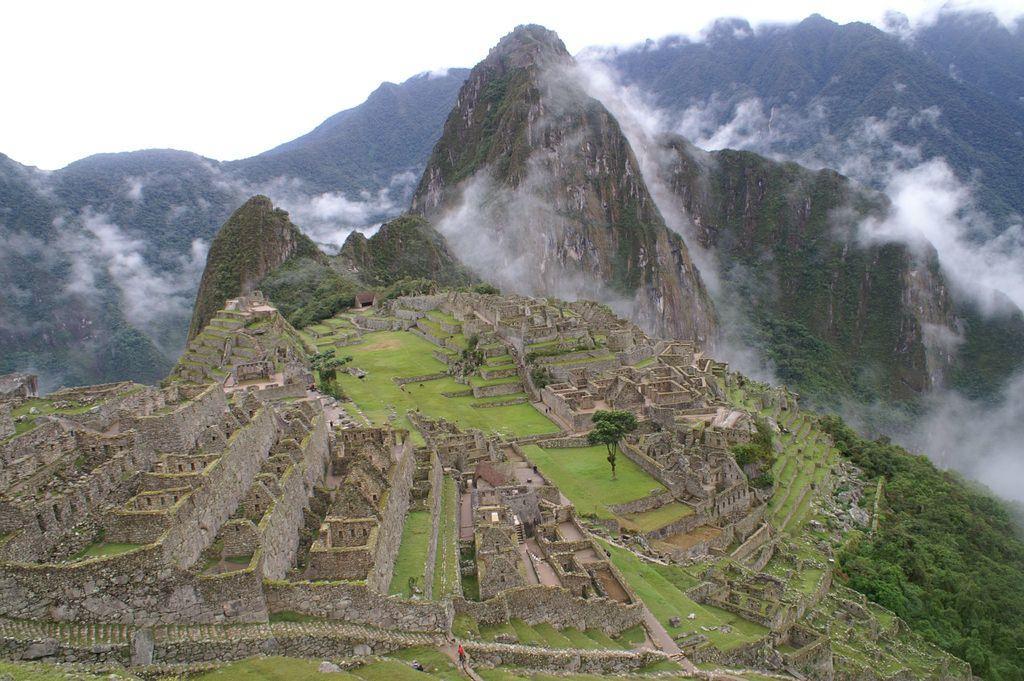Describe this image in one or two sentences. In this image I can see a top view of a city which is ruined and I can see mountains and clouds around the mountains.  